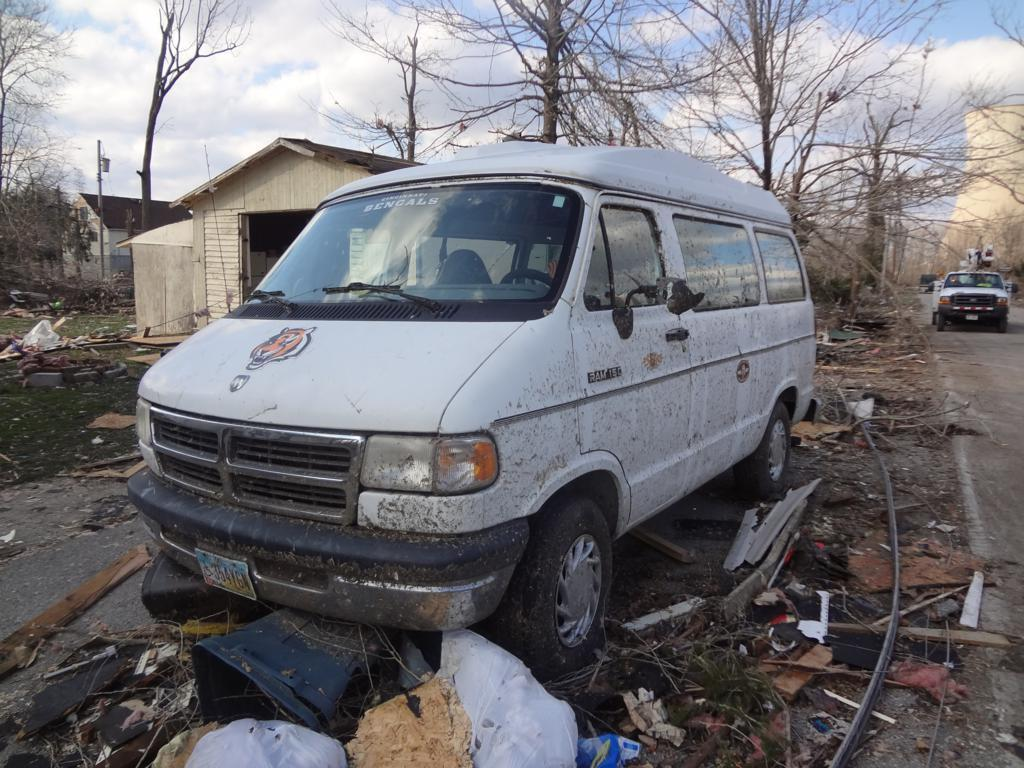<image>
Give a short and clear explanation of the subsequent image. A white van that says Ram 150 on it is parked in a pile of trash. 